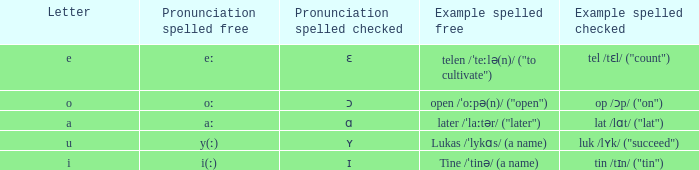What is Pronunciation Spelled Free, when Pronunciation Spelled Checked is "ɑ"? Aː. 